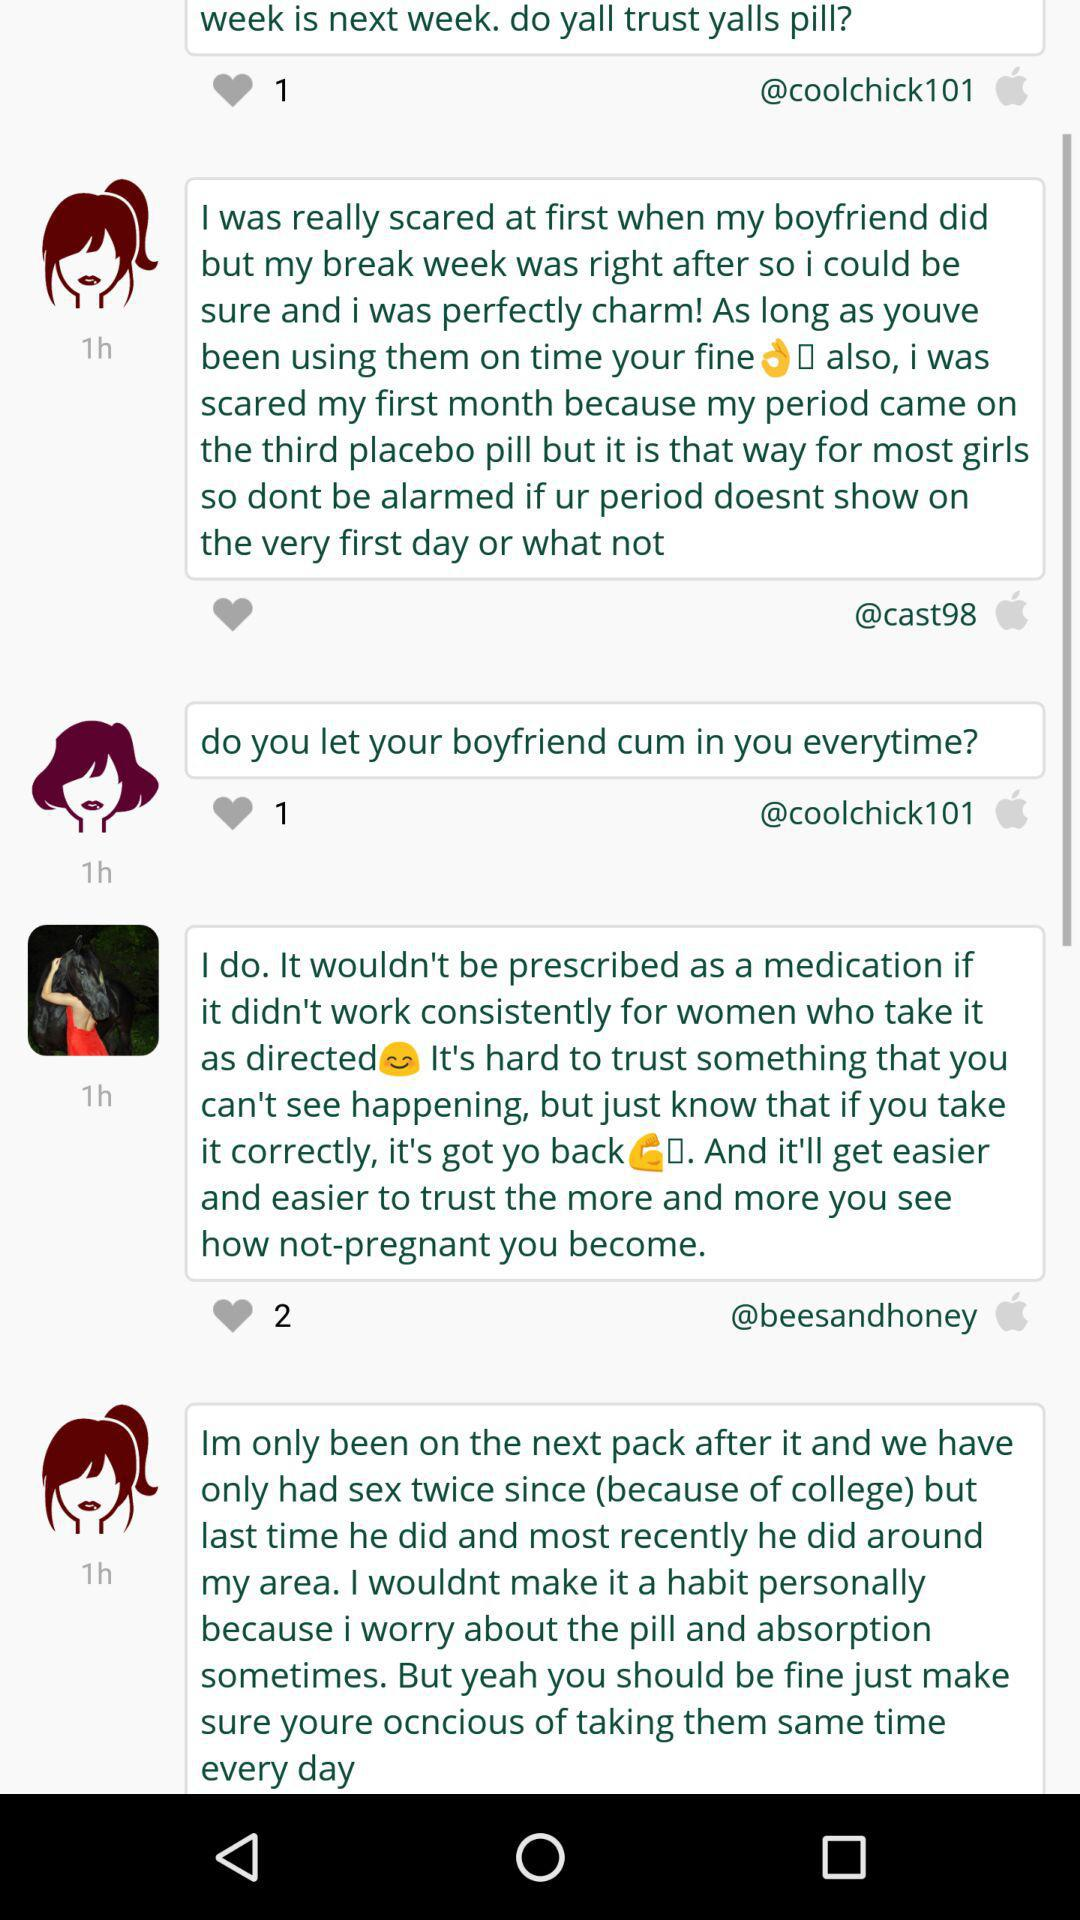How many days have you been taking the current pack?
Answer the question using a single word or phrase. 0 